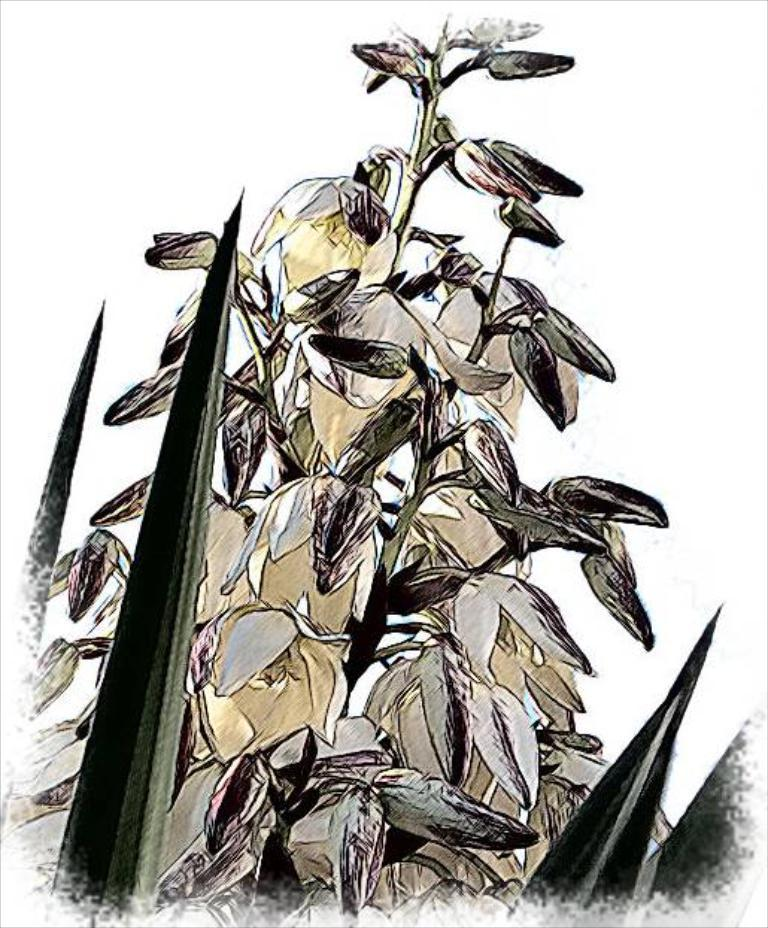What is the main subject of the image? The main subject of the image is a drawing or illustration of a plant. What specific features can be observed on the plant? The plant has flowers. What colors are the flowers? The flowers are in white and yellow color. What is the color of the background in the image? The background of the image is white in color. What type of game is being played in the image? There is no game being played in the image; it contains a drawing or illustration of a plant with flowers. What position is the person reading in the image? There is no person reading in the image; it contains a drawing or illustration of a plant with flowers. 